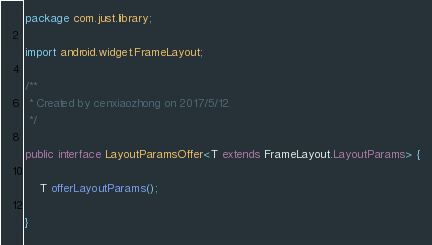<code> <loc_0><loc_0><loc_500><loc_500><_Java_>package com.just.library;

import android.widget.FrameLayout;

/**
 * Created by cenxiaozhong on 2017/5/12.
 */

public interface LayoutParamsOffer<T extends FrameLayout.LayoutParams> {

    T offerLayoutParams();

}
</code> 